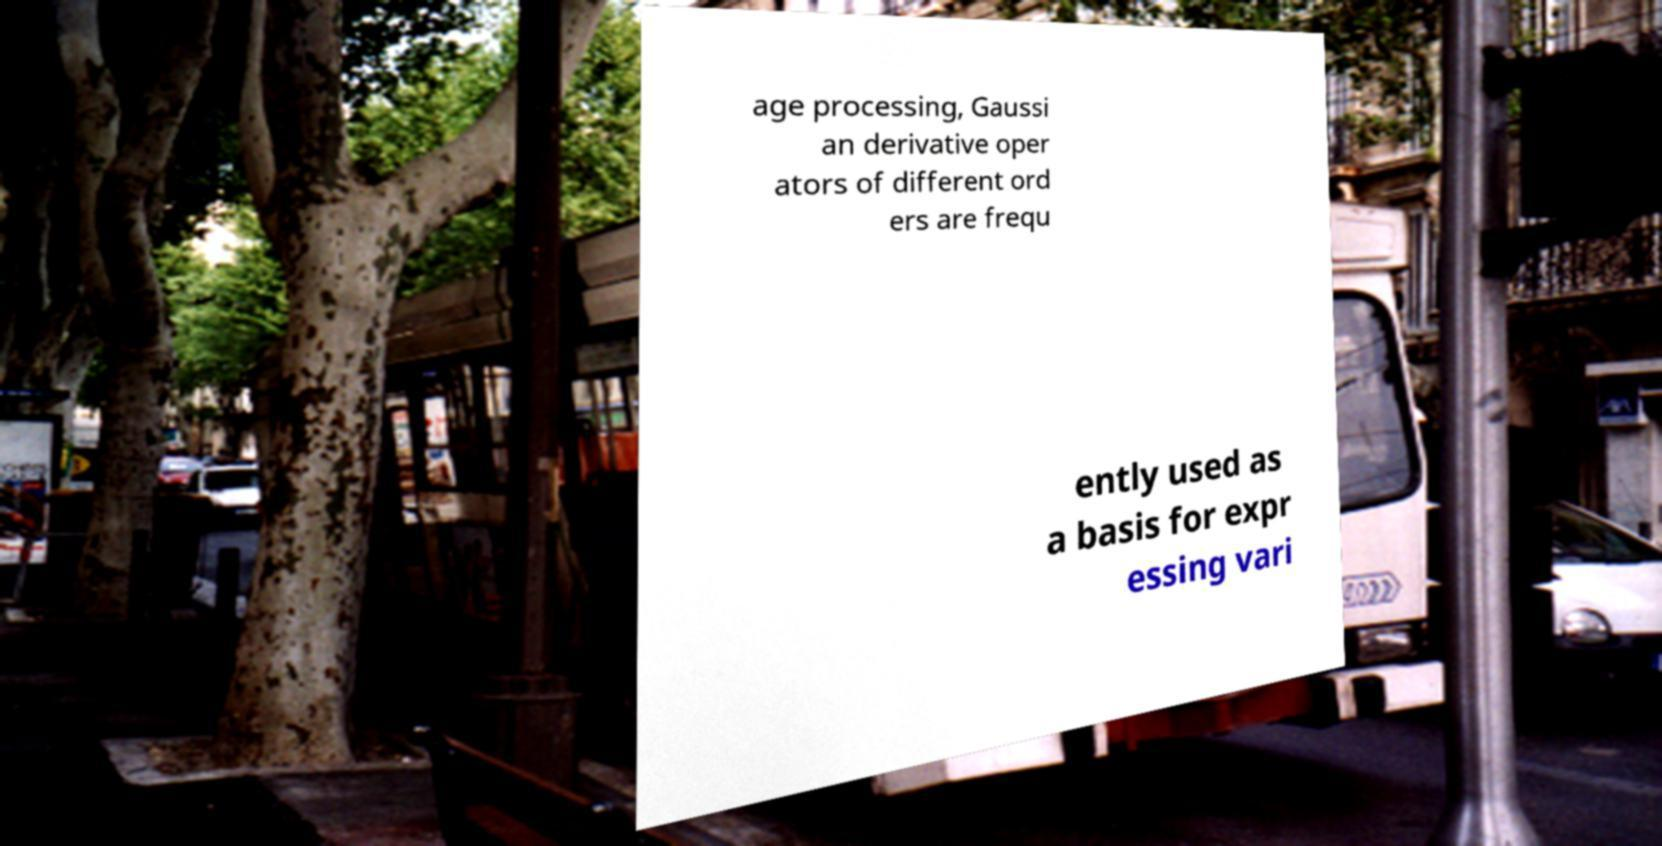Could you assist in decoding the text presented in this image and type it out clearly? age processing, Gaussi an derivative oper ators of different ord ers are frequ ently used as a basis for expr essing vari 